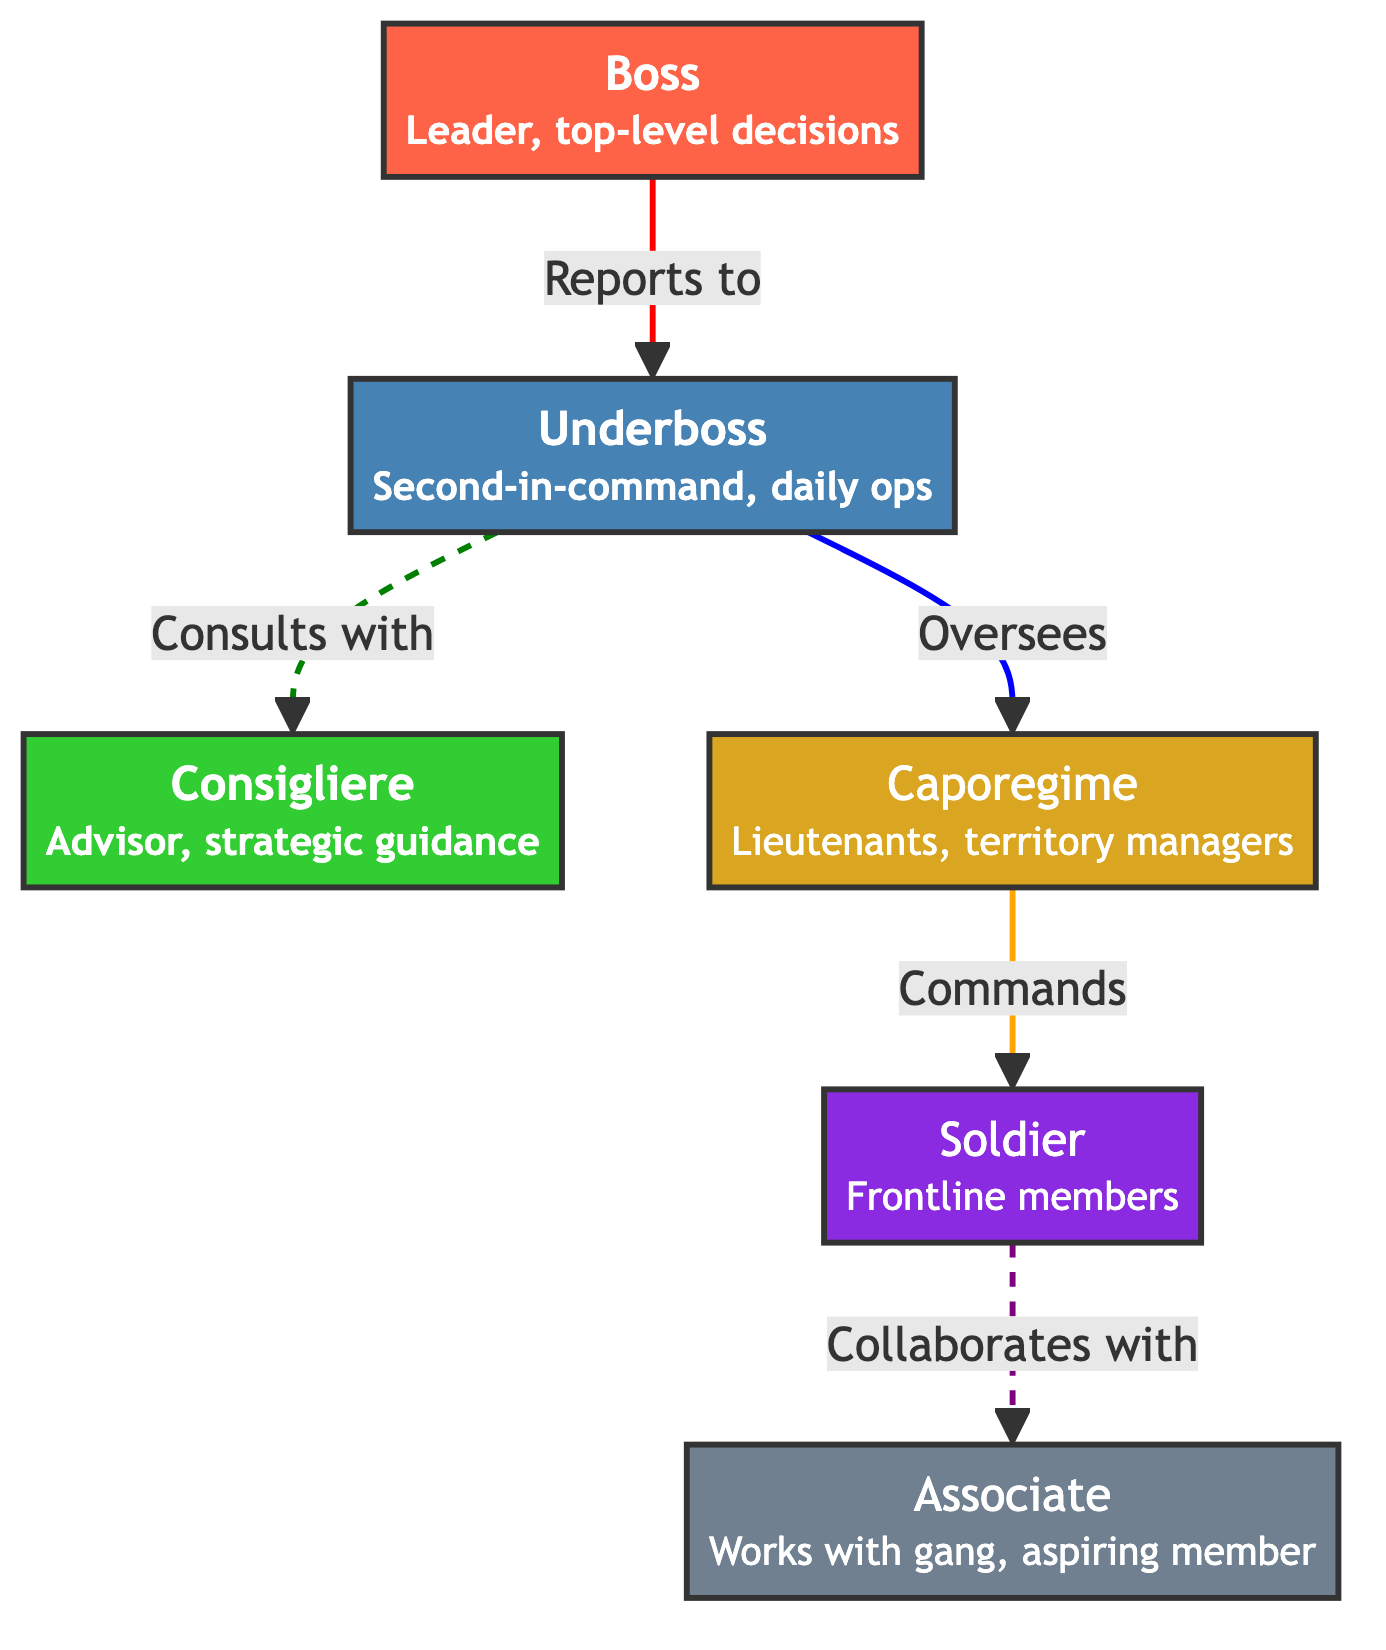What's the top-level role in the hierarchy? The diagram identifies the "Boss" as the top-level role, explicitly stating it as the "Leader, top-level decisions." This information is located at the top node of the hierarchy.
Answer: Boss How many total roles are depicted in the diagram? Counting all the roles outlined in the diagram (Boss, Underboss, Consigliere, Caporegime, Soldier, Associate), there are a total of six roles represented.
Answer: 6 Who does the Underboss oversee? The "Underboss" is responsible for overseeing the "Caporegime" roles, as indicated by the directed connection from Underboss to Caporegime in the diagram.
Answer: Caporegime What is the function of the Consigliere? The role of "Consigliere" is described in the diagram as an "Advisor, strategic guidance," which clearly defines its primary function and responsibility within the organization.
Answer: Advisor What type of relationship exists between the Underboss and the Consigliere? The diagram shows a dashed line from the Underboss to the Consigliere, which indicates a consulting relationship, suggesting the Underboss may seek advice or counsel from the Consigliere.
Answer: Consults What role commands the Soldiers? According to the diagram, the "Caporegime" is the role that "Commands" the "Soldier" members, indicating the hierarchy of authority and responsibility.
Answer: Caporegime How do the Soldiers interact with Associates? The interaction from "Soldier" to "Associate" is shown by a dashed line indicating that Soldiers "Collaborate" with Associates, suggesting a partnership or joint effort in activities.
Answer: Collaborates What is the color code representing the Boss role? The "Boss" role is represented by the color code #FF6347, which visually distinguishes it from other roles in the diagram.
Answer: #FF6347 Which role is second-in-command? The diagram specifies that the "Underboss" is the second-in-command, highlighting its position directly beneath the Boss in the hierarchy.
Answer: Underboss 